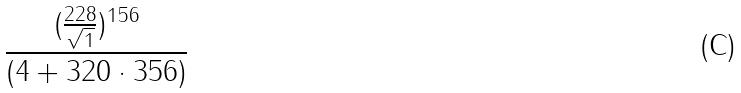Convert formula to latex. <formula><loc_0><loc_0><loc_500><loc_500>\frac { ( \frac { 2 2 8 } { \sqrt { 1 } } ) ^ { 1 5 6 } } { ( 4 + 3 2 0 \cdot 3 5 6 ) }</formula> 